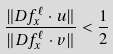<formula> <loc_0><loc_0><loc_500><loc_500>\frac { \| D f ^ { \ell } _ { x } \cdot u \| } { \| D f ^ { \ell } _ { x } \cdot v \| } < \frac { 1 } { 2 }</formula> 